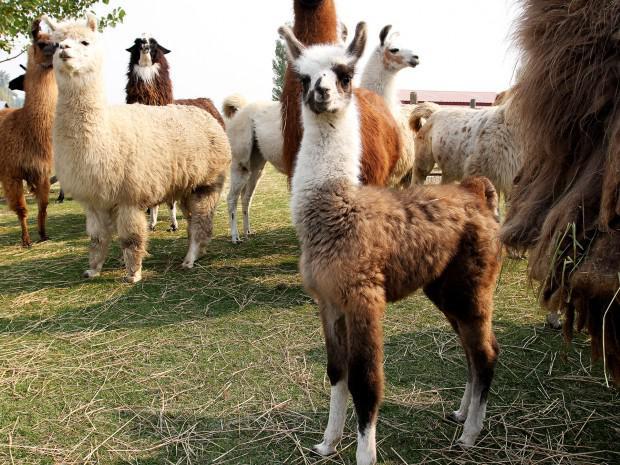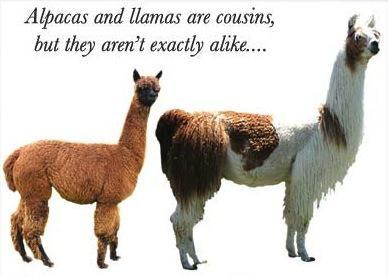The first image is the image on the left, the second image is the image on the right. Assess this claim about the two images: "At least one photo shows an animal that has had the hair on its neck shaved, and every photo has at least three animals.". Correct or not? Answer yes or no. No. The first image is the image on the left, the second image is the image on the right. Examine the images to the left and right. Is the description "At least some of the llamas have shaved necks." accurate? Answer yes or no. No. 